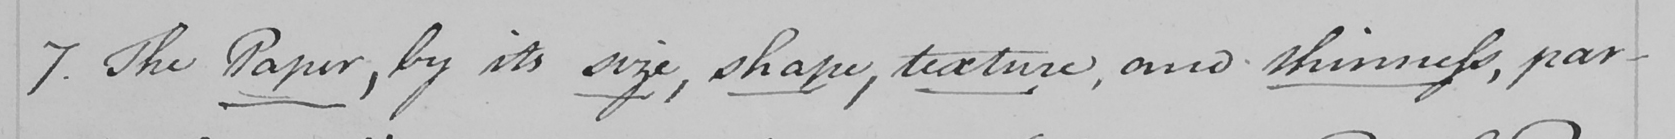Please transcribe the handwritten text in this image. 7 . The Paper , by its size , shape , texture , are thinness , par- 